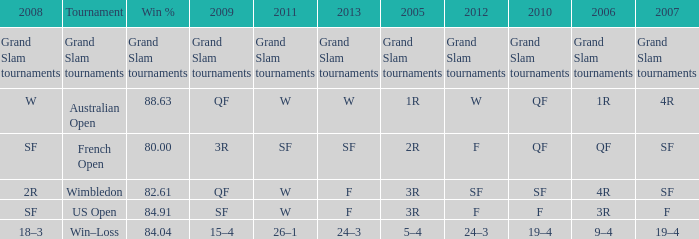Which Tournament has a 2007 of 19–4? Win–Loss. 